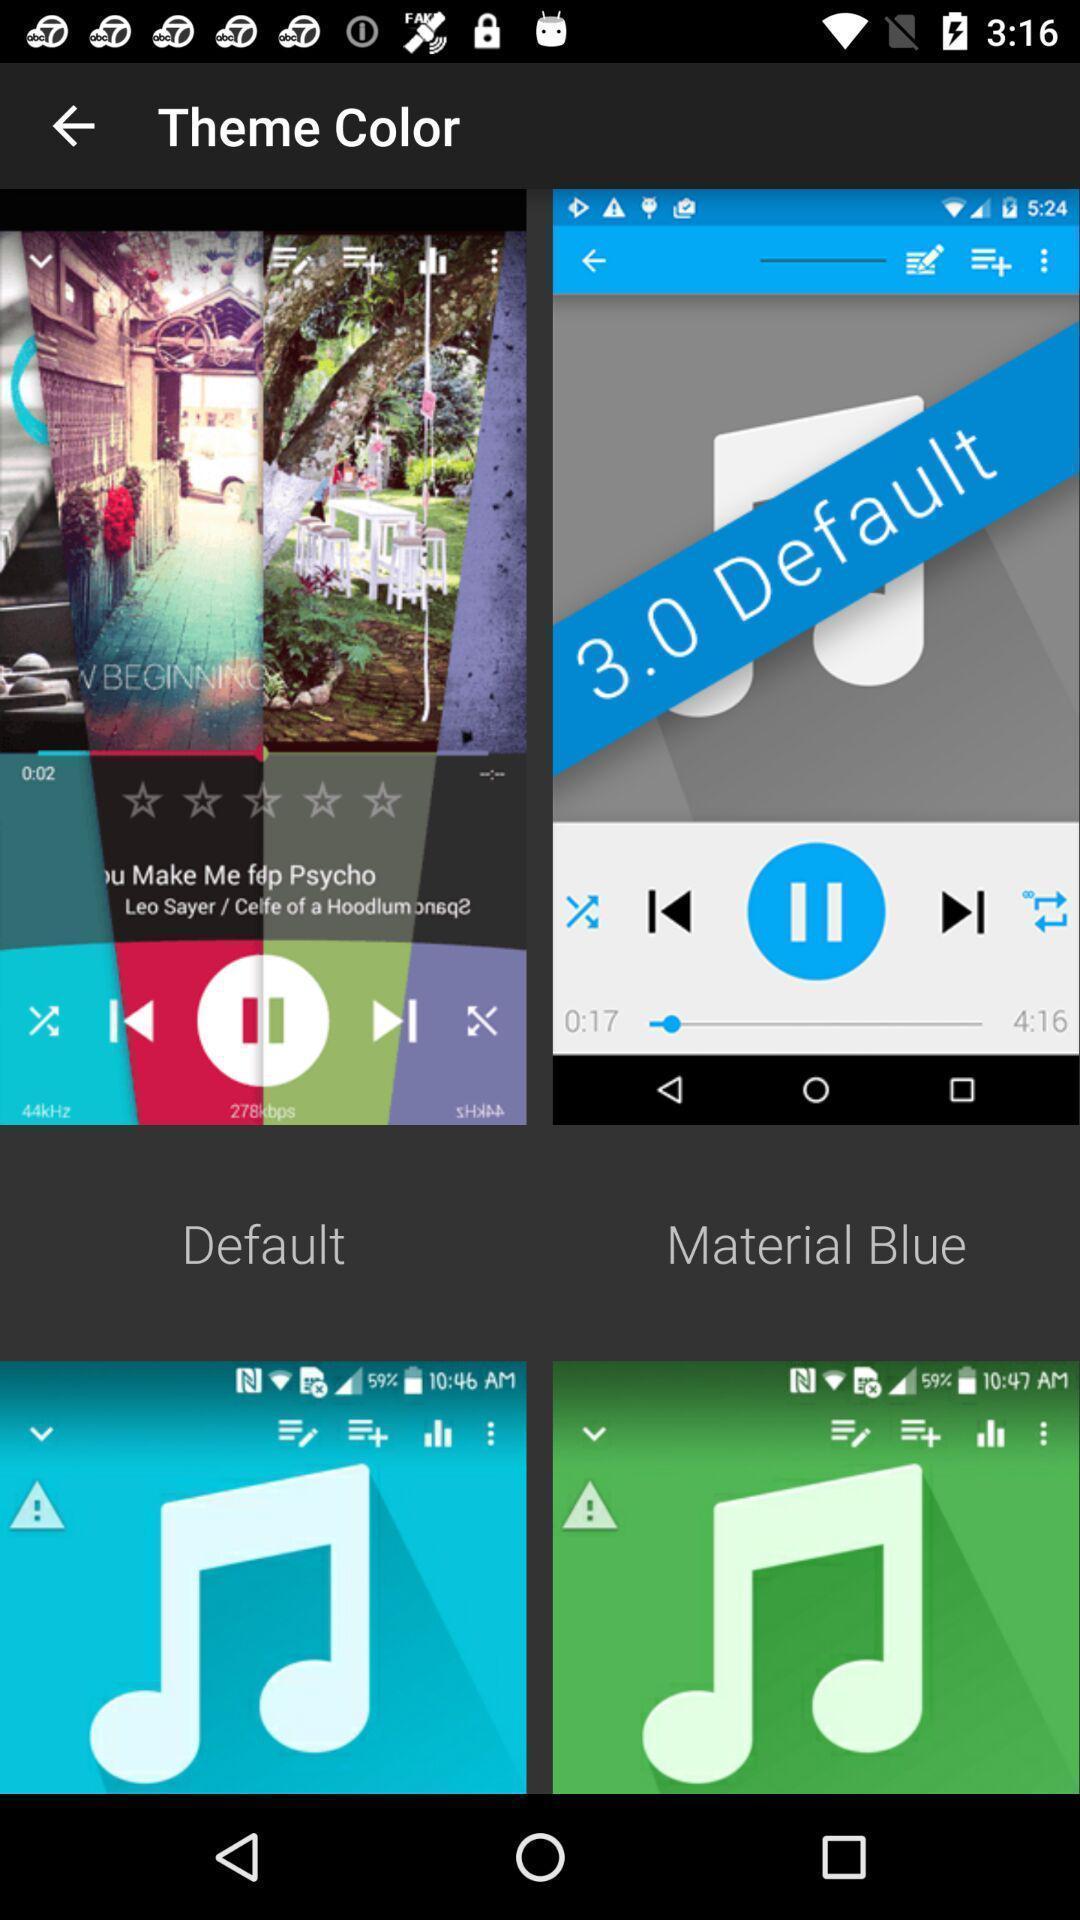Summarize the main components in this picture. Themes setting page in a music app. 